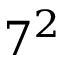<formula> <loc_0><loc_0><loc_500><loc_500>7 ^ { 2 }</formula> 